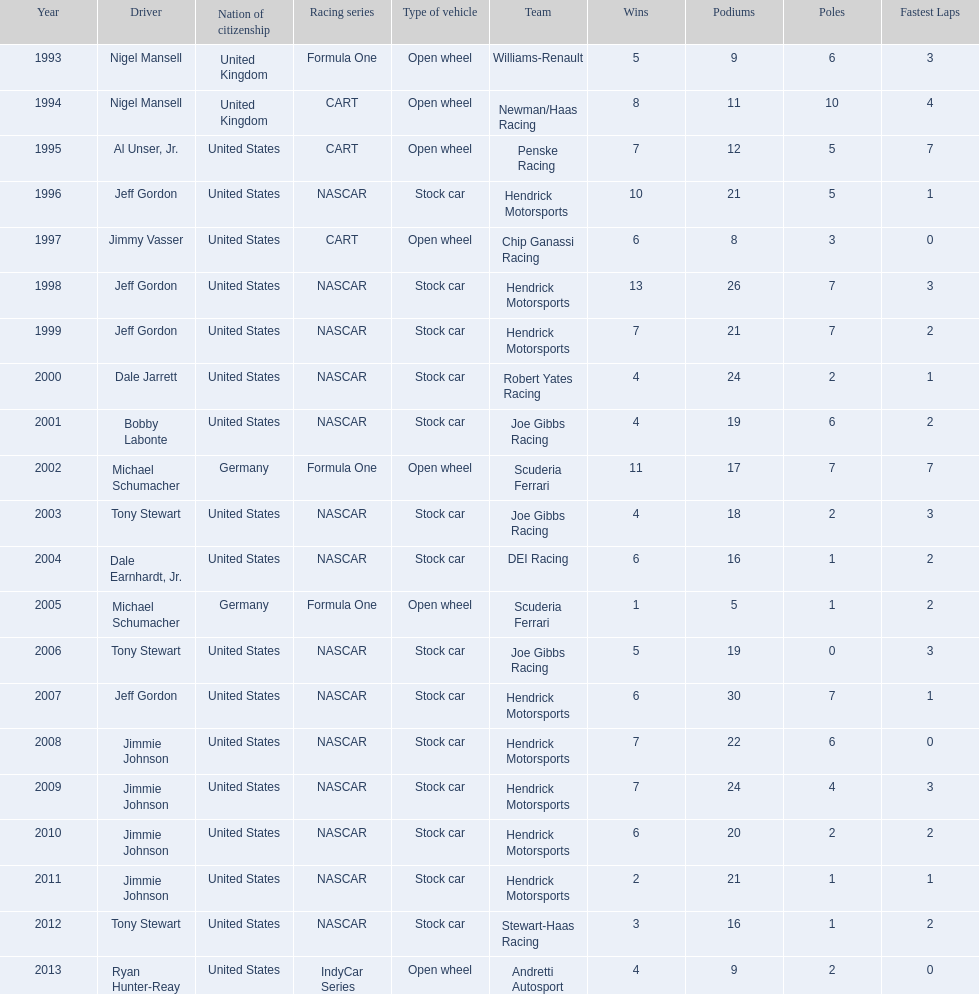What year(s) did nigel mansel receive epsy awards? 1993, 1994. What year(s) did michael schumacher receive epsy awards? 2002, 2005. Parse the table in full. {'header': ['Year', 'Driver', 'Nation of citizenship', 'Racing series', 'Type of vehicle', 'Team', 'Wins', 'Podiums', 'Poles', 'Fastest Laps'], 'rows': [['1993', 'Nigel Mansell', 'United Kingdom', 'Formula One', 'Open wheel', 'Williams-Renault', '5', '9', '6', '3'], ['1994', 'Nigel Mansell', 'United Kingdom', 'CART', 'Open wheel', 'Newman/Haas Racing', '8', '11', '10', '4'], ['1995', 'Al Unser, Jr.', 'United States', 'CART', 'Open wheel', 'Penske Racing', '7', '12', '5', '7'], ['1996', 'Jeff Gordon', 'United States', 'NASCAR', 'Stock car', 'Hendrick Motorsports ', '10', '21', '5', '1'], ['1997', 'Jimmy Vasser', 'United States', 'CART', 'Open wheel', 'Chip Ganassi Racing', '6', '8', '3', '0'], ['1998', 'Jeff Gordon', 'United States', 'NASCAR', 'Stock car', 'Hendrick Motorsports', '13', '26', '7', '3'], ['1999', 'Jeff Gordon', 'United States', 'NASCAR', 'Stock car', 'Hendrick Motorsports', '7', '21', '7', '2'], ['2000', 'Dale Jarrett', 'United States', 'NASCAR', 'Stock car', 'Robert Yates Racing', '4', '24', '2', '1'], ['2001', 'Bobby Labonte', 'United States', 'NASCAR', 'Stock car', 'Joe Gibbs Racing', '4', '19', '6', '2'], ['2002', 'Michael Schumacher', 'Germany', 'Formula One', 'Open wheel', 'Scuderia Ferrari', '11', '17', '7', '7'], ['2003', 'Tony Stewart', 'United States', 'NASCAR', 'Stock car', 'Joe Gibbs Racing', '4', '18', '2', '3'], ['2004', 'Dale Earnhardt, Jr.', 'United States', 'NASCAR', 'Stock car', 'DEI Racing', '6', '16', '1', '2'], ['2005', 'Michael Schumacher', 'Germany', 'Formula One', 'Open wheel', 'Scuderia Ferrari', '1', '5', '1', '2'], ['2006', 'Tony Stewart', 'United States', 'NASCAR', 'Stock car', 'Joe Gibbs Racing', '5', '19', '0', '3'], ['2007', 'Jeff Gordon', 'United States', 'NASCAR', 'Stock car', 'Hendrick Motorsports', '6', '30', '7', '1'], ['2008', 'Jimmie Johnson', 'United States', 'NASCAR', 'Stock car', 'Hendrick Motorsports', '7', '22', '6', '0'], ['2009', 'Jimmie Johnson', 'United States', 'NASCAR', 'Stock car', 'Hendrick Motorsports', '7', '24', '4', '3'], ['2010', 'Jimmie Johnson', 'United States', 'NASCAR', 'Stock car', 'Hendrick Motorsports', '6', '20', '2', '2'], ['2011', 'Jimmie Johnson', 'United States', 'NASCAR', 'Stock car', 'Hendrick Motorsports', '2', '21', '1', '1'], ['2012', 'Tony Stewart', 'United States', 'NASCAR', 'Stock car', 'Stewart-Haas Racing', '3', '16', '1', '2'], ['2013', 'Ryan Hunter-Reay', 'United States', 'IndyCar Series', 'Open wheel', 'Andretti Autosport', '4', '9', '2', '0']]} What year(s) did jeff gordon receive epsy awards? 1996, 1998, 1999, 2007. What year(s) did al unser jr. receive epsy awards? 1995. Which driver only received one epsy award? Al Unser, Jr. 